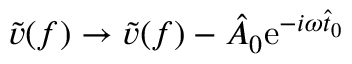<formula> <loc_0><loc_0><loc_500><loc_500>\tilde { v } ( f ) \to \tilde { v } ( f ) - \hat { A } _ { 0 } e ^ { - i \omega \hat { t } _ { 0 } }</formula> 